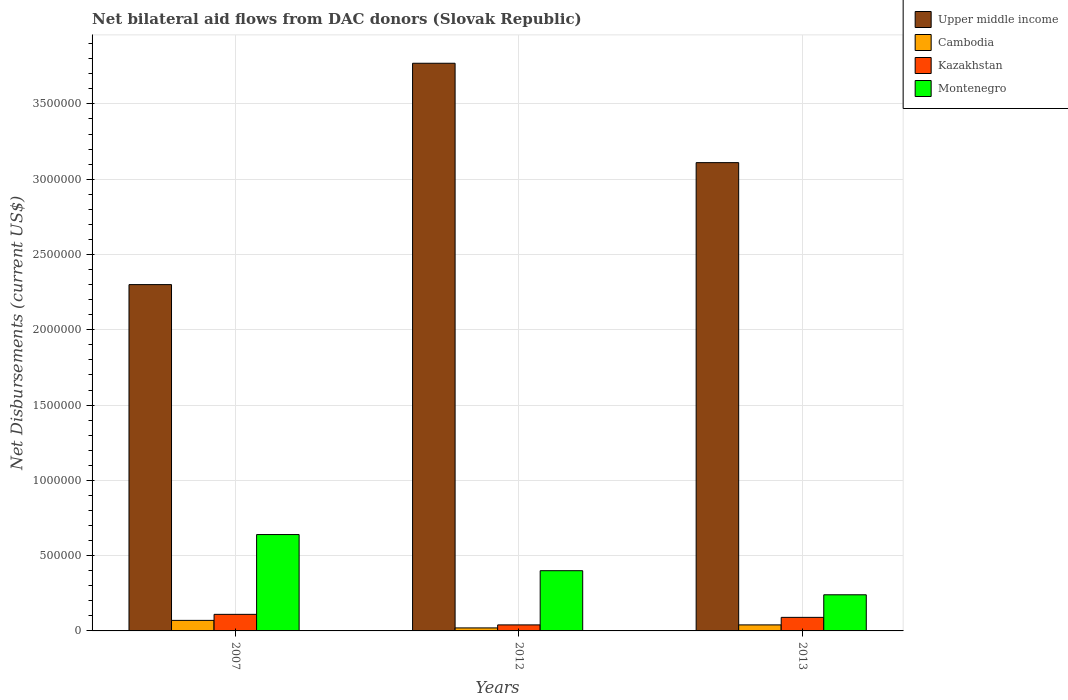How many different coloured bars are there?
Keep it short and to the point. 4. Are the number of bars per tick equal to the number of legend labels?
Provide a short and direct response. Yes. Are the number of bars on each tick of the X-axis equal?
Ensure brevity in your answer.  Yes. What is the label of the 3rd group of bars from the left?
Your response must be concise. 2013. In how many cases, is the number of bars for a given year not equal to the number of legend labels?
Your response must be concise. 0. Across all years, what is the minimum net bilateral aid flows in Montenegro?
Keep it short and to the point. 2.40e+05. In which year was the net bilateral aid flows in Cambodia minimum?
Provide a succinct answer. 2012. What is the total net bilateral aid flows in Montenegro in the graph?
Make the answer very short. 1.28e+06. What is the difference between the net bilateral aid flows in Upper middle income in 2007 and that in 2012?
Your response must be concise. -1.47e+06. What is the average net bilateral aid flows in Upper middle income per year?
Make the answer very short. 3.06e+06. In the year 2012, what is the difference between the net bilateral aid flows in Upper middle income and net bilateral aid flows in Montenegro?
Ensure brevity in your answer.  3.37e+06. Is the net bilateral aid flows in Cambodia in 2007 less than that in 2012?
Keep it short and to the point. No. What is the difference between the highest and the lowest net bilateral aid flows in Upper middle income?
Your answer should be very brief. 1.47e+06. In how many years, is the net bilateral aid flows in Cambodia greater than the average net bilateral aid flows in Cambodia taken over all years?
Provide a succinct answer. 1. Is the sum of the net bilateral aid flows in Upper middle income in 2007 and 2013 greater than the maximum net bilateral aid flows in Cambodia across all years?
Ensure brevity in your answer.  Yes. Is it the case that in every year, the sum of the net bilateral aid flows in Montenegro and net bilateral aid flows in Cambodia is greater than the sum of net bilateral aid flows in Upper middle income and net bilateral aid flows in Kazakhstan?
Offer a terse response. No. What does the 1st bar from the left in 2013 represents?
Offer a terse response. Upper middle income. What does the 4th bar from the right in 2012 represents?
Your answer should be very brief. Upper middle income. Is it the case that in every year, the sum of the net bilateral aid flows in Kazakhstan and net bilateral aid flows in Cambodia is greater than the net bilateral aid flows in Montenegro?
Give a very brief answer. No. How many bars are there?
Provide a succinct answer. 12. Are all the bars in the graph horizontal?
Provide a succinct answer. No. How many years are there in the graph?
Provide a short and direct response. 3. Does the graph contain grids?
Offer a terse response. Yes. What is the title of the graph?
Provide a short and direct response. Net bilateral aid flows from DAC donors (Slovak Republic). What is the label or title of the X-axis?
Your answer should be compact. Years. What is the label or title of the Y-axis?
Offer a very short reply. Net Disbursements (current US$). What is the Net Disbursements (current US$) of Upper middle income in 2007?
Your answer should be very brief. 2.30e+06. What is the Net Disbursements (current US$) in Montenegro in 2007?
Offer a terse response. 6.40e+05. What is the Net Disbursements (current US$) of Upper middle income in 2012?
Ensure brevity in your answer.  3.77e+06. What is the Net Disbursements (current US$) in Cambodia in 2012?
Give a very brief answer. 2.00e+04. What is the Net Disbursements (current US$) in Upper middle income in 2013?
Keep it short and to the point. 3.11e+06. What is the Net Disbursements (current US$) of Cambodia in 2013?
Give a very brief answer. 4.00e+04. What is the Net Disbursements (current US$) in Kazakhstan in 2013?
Your response must be concise. 9.00e+04. Across all years, what is the maximum Net Disbursements (current US$) in Upper middle income?
Offer a terse response. 3.77e+06. Across all years, what is the maximum Net Disbursements (current US$) of Kazakhstan?
Provide a succinct answer. 1.10e+05. Across all years, what is the maximum Net Disbursements (current US$) of Montenegro?
Offer a terse response. 6.40e+05. Across all years, what is the minimum Net Disbursements (current US$) in Upper middle income?
Ensure brevity in your answer.  2.30e+06. Across all years, what is the minimum Net Disbursements (current US$) in Montenegro?
Provide a succinct answer. 2.40e+05. What is the total Net Disbursements (current US$) of Upper middle income in the graph?
Ensure brevity in your answer.  9.18e+06. What is the total Net Disbursements (current US$) in Montenegro in the graph?
Provide a short and direct response. 1.28e+06. What is the difference between the Net Disbursements (current US$) of Upper middle income in 2007 and that in 2012?
Make the answer very short. -1.47e+06. What is the difference between the Net Disbursements (current US$) in Cambodia in 2007 and that in 2012?
Keep it short and to the point. 5.00e+04. What is the difference between the Net Disbursements (current US$) of Kazakhstan in 2007 and that in 2012?
Your response must be concise. 7.00e+04. What is the difference between the Net Disbursements (current US$) of Upper middle income in 2007 and that in 2013?
Provide a succinct answer. -8.10e+05. What is the difference between the Net Disbursements (current US$) of Cambodia in 2007 and that in 2013?
Ensure brevity in your answer.  3.00e+04. What is the difference between the Net Disbursements (current US$) in Cambodia in 2012 and that in 2013?
Keep it short and to the point. -2.00e+04. What is the difference between the Net Disbursements (current US$) of Upper middle income in 2007 and the Net Disbursements (current US$) of Cambodia in 2012?
Keep it short and to the point. 2.28e+06. What is the difference between the Net Disbursements (current US$) in Upper middle income in 2007 and the Net Disbursements (current US$) in Kazakhstan in 2012?
Ensure brevity in your answer.  2.26e+06. What is the difference between the Net Disbursements (current US$) in Upper middle income in 2007 and the Net Disbursements (current US$) in Montenegro in 2012?
Your answer should be compact. 1.90e+06. What is the difference between the Net Disbursements (current US$) in Cambodia in 2007 and the Net Disbursements (current US$) in Montenegro in 2012?
Ensure brevity in your answer.  -3.30e+05. What is the difference between the Net Disbursements (current US$) in Upper middle income in 2007 and the Net Disbursements (current US$) in Cambodia in 2013?
Provide a succinct answer. 2.26e+06. What is the difference between the Net Disbursements (current US$) of Upper middle income in 2007 and the Net Disbursements (current US$) of Kazakhstan in 2013?
Offer a terse response. 2.21e+06. What is the difference between the Net Disbursements (current US$) of Upper middle income in 2007 and the Net Disbursements (current US$) of Montenegro in 2013?
Your answer should be very brief. 2.06e+06. What is the difference between the Net Disbursements (current US$) of Kazakhstan in 2007 and the Net Disbursements (current US$) of Montenegro in 2013?
Make the answer very short. -1.30e+05. What is the difference between the Net Disbursements (current US$) in Upper middle income in 2012 and the Net Disbursements (current US$) in Cambodia in 2013?
Provide a succinct answer. 3.73e+06. What is the difference between the Net Disbursements (current US$) in Upper middle income in 2012 and the Net Disbursements (current US$) in Kazakhstan in 2013?
Ensure brevity in your answer.  3.68e+06. What is the difference between the Net Disbursements (current US$) in Upper middle income in 2012 and the Net Disbursements (current US$) in Montenegro in 2013?
Give a very brief answer. 3.53e+06. What is the difference between the Net Disbursements (current US$) in Cambodia in 2012 and the Net Disbursements (current US$) in Kazakhstan in 2013?
Ensure brevity in your answer.  -7.00e+04. What is the average Net Disbursements (current US$) in Upper middle income per year?
Give a very brief answer. 3.06e+06. What is the average Net Disbursements (current US$) in Cambodia per year?
Your answer should be compact. 4.33e+04. What is the average Net Disbursements (current US$) of Montenegro per year?
Your answer should be very brief. 4.27e+05. In the year 2007, what is the difference between the Net Disbursements (current US$) of Upper middle income and Net Disbursements (current US$) of Cambodia?
Ensure brevity in your answer.  2.23e+06. In the year 2007, what is the difference between the Net Disbursements (current US$) of Upper middle income and Net Disbursements (current US$) of Kazakhstan?
Your response must be concise. 2.19e+06. In the year 2007, what is the difference between the Net Disbursements (current US$) in Upper middle income and Net Disbursements (current US$) in Montenegro?
Provide a short and direct response. 1.66e+06. In the year 2007, what is the difference between the Net Disbursements (current US$) in Cambodia and Net Disbursements (current US$) in Montenegro?
Your answer should be very brief. -5.70e+05. In the year 2007, what is the difference between the Net Disbursements (current US$) in Kazakhstan and Net Disbursements (current US$) in Montenegro?
Your answer should be compact. -5.30e+05. In the year 2012, what is the difference between the Net Disbursements (current US$) of Upper middle income and Net Disbursements (current US$) of Cambodia?
Provide a short and direct response. 3.75e+06. In the year 2012, what is the difference between the Net Disbursements (current US$) in Upper middle income and Net Disbursements (current US$) in Kazakhstan?
Keep it short and to the point. 3.73e+06. In the year 2012, what is the difference between the Net Disbursements (current US$) in Upper middle income and Net Disbursements (current US$) in Montenegro?
Provide a succinct answer. 3.37e+06. In the year 2012, what is the difference between the Net Disbursements (current US$) of Cambodia and Net Disbursements (current US$) of Kazakhstan?
Offer a terse response. -2.00e+04. In the year 2012, what is the difference between the Net Disbursements (current US$) of Cambodia and Net Disbursements (current US$) of Montenegro?
Make the answer very short. -3.80e+05. In the year 2012, what is the difference between the Net Disbursements (current US$) in Kazakhstan and Net Disbursements (current US$) in Montenegro?
Your response must be concise. -3.60e+05. In the year 2013, what is the difference between the Net Disbursements (current US$) of Upper middle income and Net Disbursements (current US$) of Cambodia?
Provide a short and direct response. 3.07e+06. In the year 2013, what is the difference between the Net Disbursements (current US$) of Upper middle income and Net Disbursements (current US$) of Kazakhstan?
Make the answer very short. 3.02e+06. In the year 2013, what is the difference between the Net Disbursements (current US$) of Upper middle income and Net Disbursements (current US$) of Montenegro?
Provide a short and direct response. 2.87e+06. In the year 2013, what is the difference between the Net Disbursements (current US$) in Cambodia and Net Disbursements (current US$) in Kazakhstan?
Your response must be concise. -5.00e+04. In the year 2013, what is the difference between the Net Disbursements (current US$) of Kazakhstan and Net Disbursements (current US$) of Montenegro?
Keep it short and to the point. -1.50e+05. What is the ratio of the Net Disbursements (current US$) in Upper middle income in 2007 to that in 2012?
Offer a very short reply. 0.61. What is the ratio of the Net Disbursements (current US$) in Cambodia in 2007 to that in 2012?
Ensure brevity in your answer.  3.5. What is the ratio of the Net Disbursements (current US$) of Kazakhstan in 2007 to that in 2012?
Ensure brevity in your answer.  2.75. What is the ratio of the Net Disbursements (current US$) of Upper middle income in 2007 to that in 2013?
Provide a short and direct response. 0.74. What is the ratio of the Net Disbursements (current US$) in Cambodia in 2007 to that in 2013?
Offer a terse response. 1.75. What is the ratio of the Net Disbursements (current US$) of Kazakhstan in 2007 to that in 2013?
Offer a terse response. 1.22. What is the ratio of the Net Disbursements (current US$) in Montenegro in 2007 to that in 2013?
Provide a short and direct response. 2.67. What is the ratio of the Net Disbursements (current US$) in Upper middle income in 2012 to that in 2013?
Your answer should be very brief. 1.21. What is the ratio of the Net Disbursements (current US$) of Kazakhstan in 2012 to that in 2013?
Provide a short and direct response. 0.44. What is the ratio of the Net Disbursements (current US$) in Montenegro in 2012 to that in 2013?
Give a very brief answer. 1.67. What is the difference between the highest and the second highest Net Disbursements (current US$) of Cambodia?
Provide a succinct answer. 3.00e+04. What is the difference between the highest and the second highest Net Disbursements (current US$) of Kazakhstan?
Make the answer very short. 2.00e+04. What is the difference between the highest and the second highest Net Disbursements (current US$) in Montenegro?
Your response must be concise. 2.40e+05. What is the difference between the highest and the lowest Net Disbursements (current US$) of Upper middle income?
Offer a very short reply. 1.47e+06. What is the difference between the highest and the lowest Net Disbursements (current US$) of Cambodia?
Offer a very short reply. 5.00e+04. What is the difference between the highest and the lowest Net Disbursements (current US$) of Kazakhstan?
Your response must be concise. 7.00e+04. What is the difference between the highest and the lowest Net Disbursements (current US$) in Montenegro?
Your answer should be very brief. 4.00e+05. 